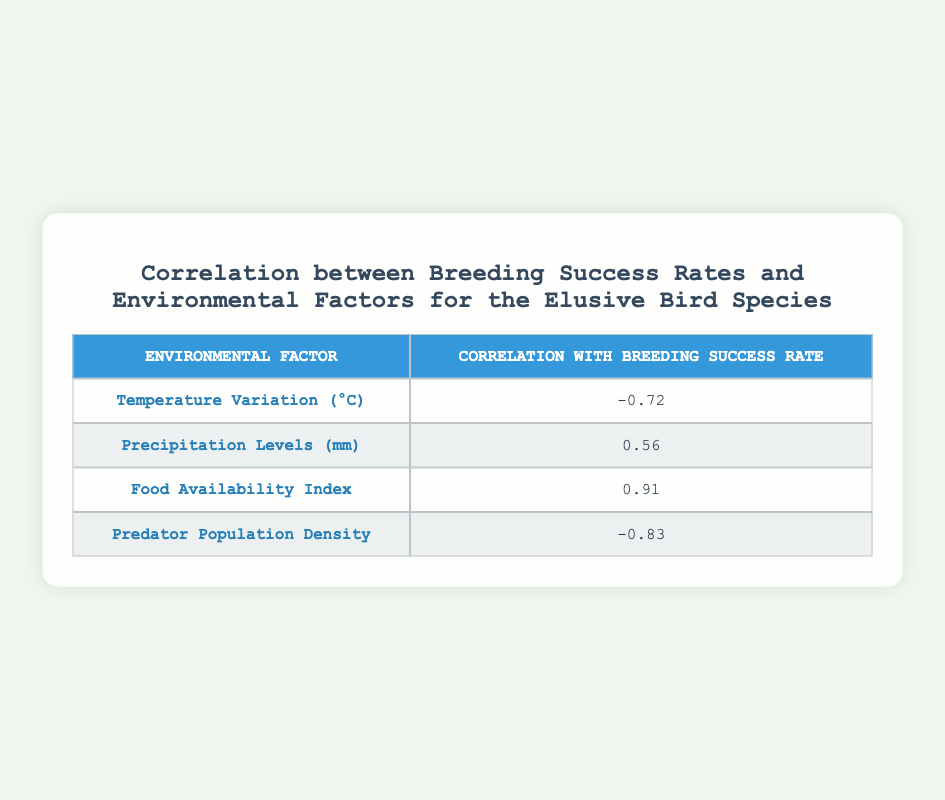What is the correlation between food availability index and breeding success rates? The table shows that the correlation between food availability index and breeding success rates is 0.91.
Answer: 0.91 Which environmental factor shows the highest negative correlation with breeding success rates? The highest negative correlation with breeding success rates is shown by predator population density with a correlation of -0.83.
Answer: -0.83 What is the average correlation of temperature variation and precipitation levels with breeding success rates? The correlations for temperature variation and precipitation levels are -0.72 and 0.56, respectively. To find the average, we sum them: (-0.72 + 0.56) / 2 = -0.08.
Answer: -0.08 Is there a positive correlation between precipitation levels and breeding success rates? Yes, the correlation for precipitation levels is 0.56, which indicates a positive relationship with breeding success rates.
Answer: Yes If the food availability index increases, how does it affect breeding success rates? The correlation for food availability index is 0.91, indicating a strong positive relationship. Therefore, increases in food availability should lead to increases in breeding success rates.
Answer: Increases lead to increases 